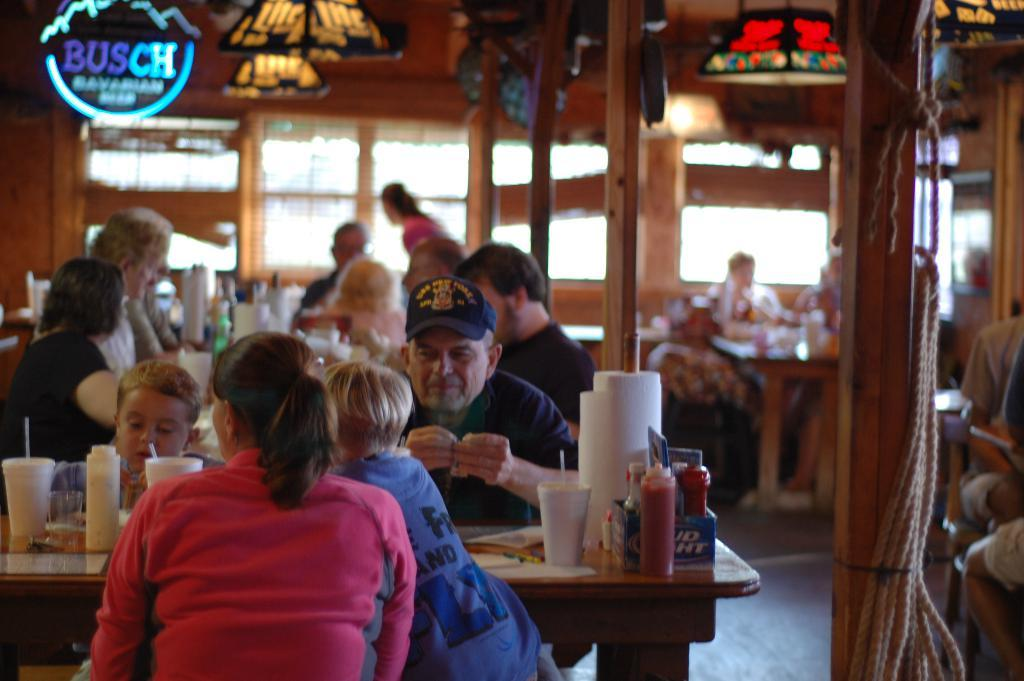What are the people in the image doing? The people in the image are sitting on chairs. What else can be seen in the image besides the people? There are tables in the image. What is on the tables? There are many things on the tables. What can be seen in the background of the image? There are lights visible in the background of the image. How many cobwebs are present on the furniture in the image? There is no mention of cobwebs or furniture in the image, so it cannot be determined if any cobwebs are present. 